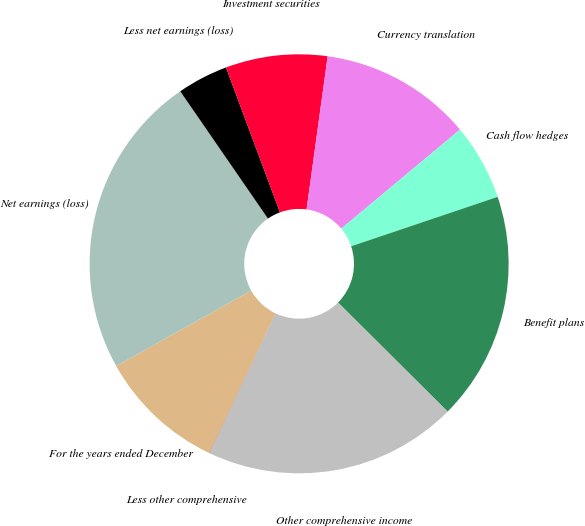<chart> <loc_0><loc_0><loc_500><loc_500><pie_chart><fcel>For the years ended December<fcel>Net earnings (loss)<fcel>Less net earnings (loss)<fcel>Investment securities<fcel>Currency translation<fcel>Cash flow hedges<fcel>Benefit plans<fcel>Other comprehensive income<fcel>Less other comprehensive<nl><fcel>9.81%<fcel>23.51%<fcel>3.93%<fcel>7.85%<fcel>11.76%<fcel>5.89%<fcel>17.64%<fcel>19.6%<fcel>0.02%<nl></chart> 